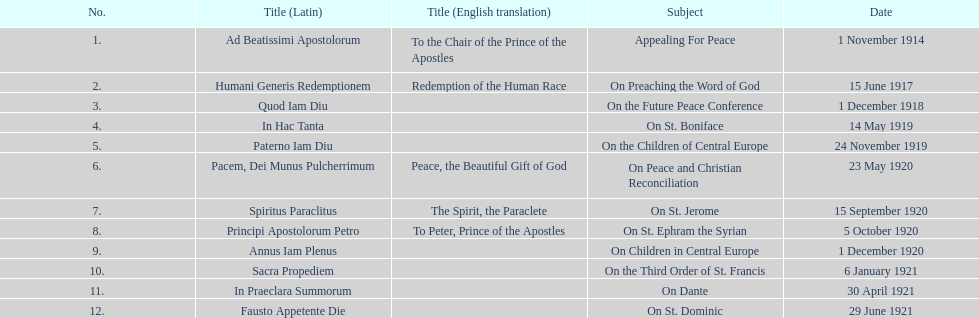After december 1, 1918, on which date was the next encyclical released? 14 May 1919. 